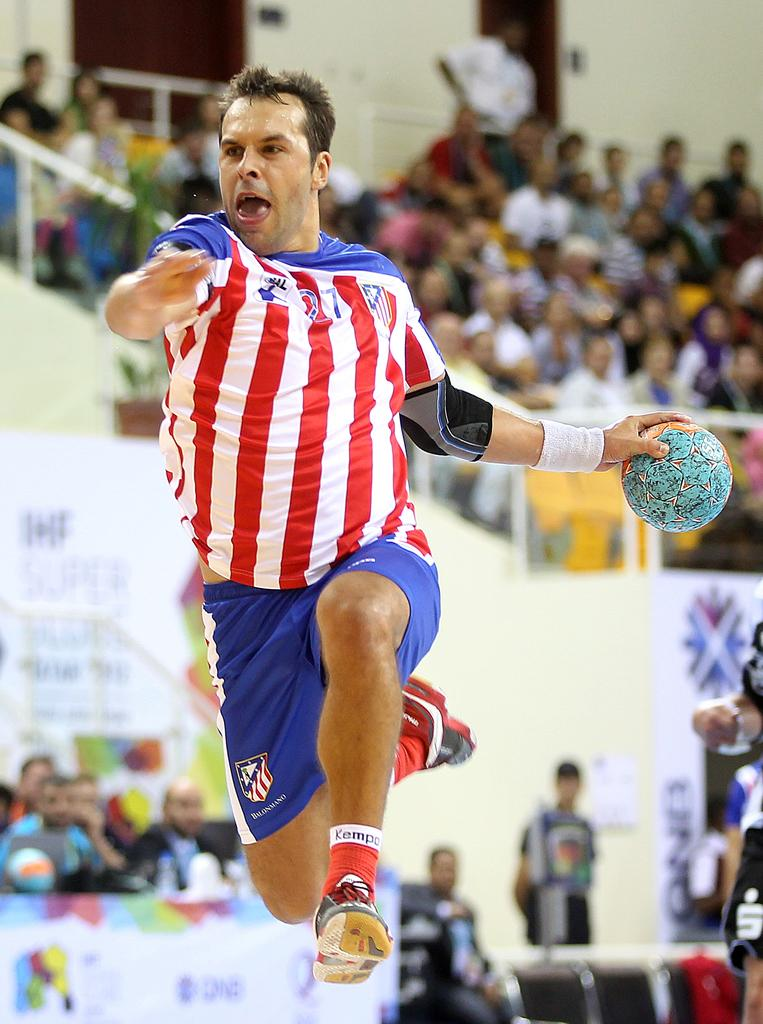What is the man in the image doing? The man is jumping with a ball in the image. Can you describe the people in the background of the image? Some people in the background are sitting on chairs, while others are standing. How does the background appear in the image? The background appears blurred. How many wings can be seen on the man in the image? There are no wings visible on the man in the image. What type of balls are being juggled by the people in the background? There are no balls being juggled by people in the background; the man in the image is the one jumping with a ball. 